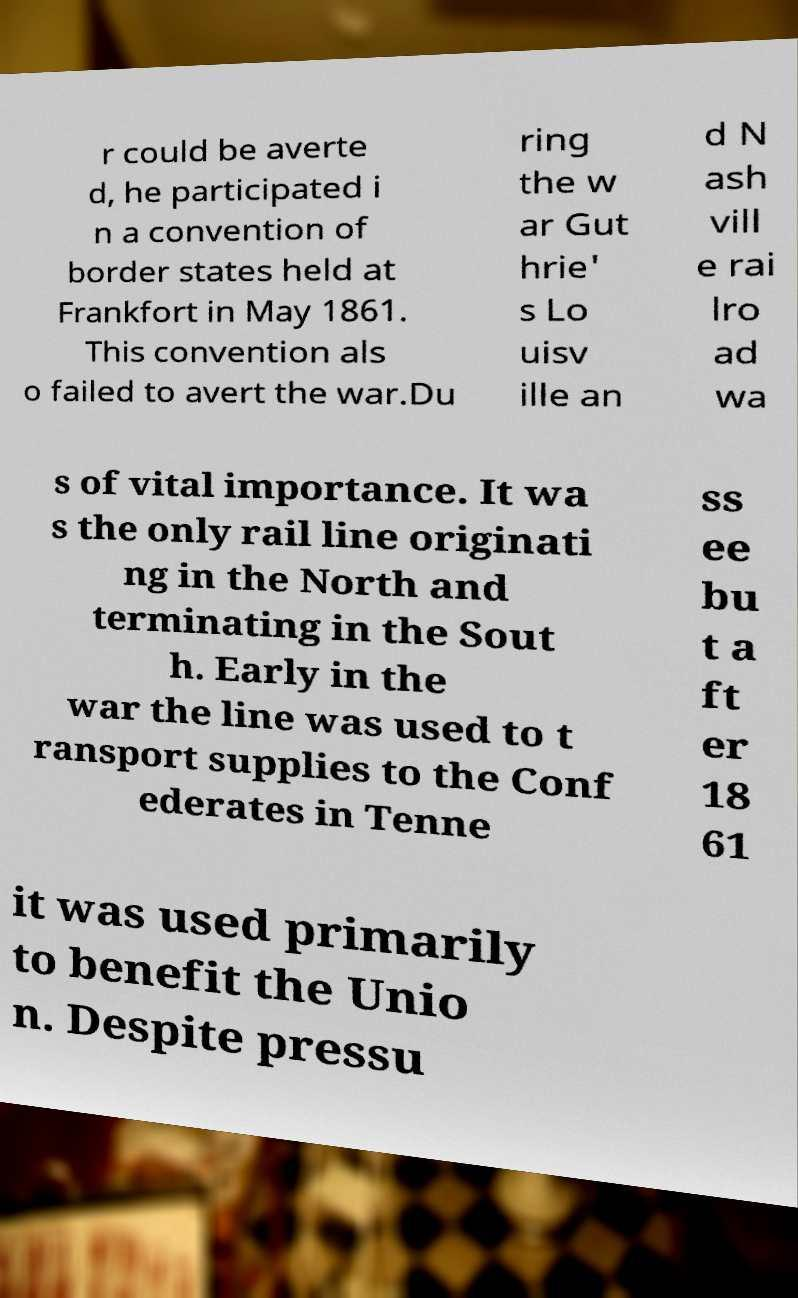Can you accurately transcribe the text from the provided image for me? r could be averte d, he participated i n a convention of border states held at Frankfort in May 1861. This convention als o failed to avert the war.Du ring the w ar Gut hrie' s Lo uisv ille an d N ash vill e rai lro ad wa s of vital importance. It wa s the only rail line originati ng in the North and terminating in the Sout h. Early in the war the line was used to t ransport supplies to the Conf ederates in Tenne ss ee bu t a ft er 18 61 it was used primarily to benefit the Unio n. Despite pressu 